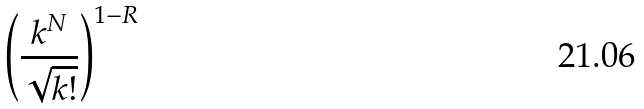<formula> <loc_0><loc_0><loc_500><loc_500>\left ( \frac { k ^ { N } } { \sqrt { k ! } } \right ) ^ { 1 - R }</formula> 